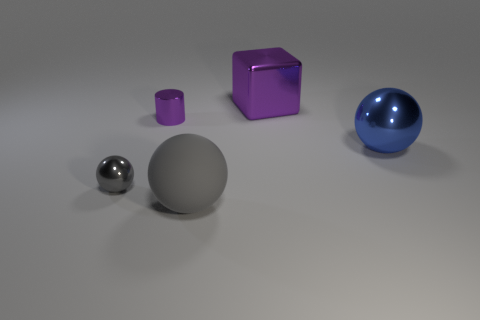What is the color of the other big metallic thing that is the same shape as the gray metallic thing?
Ensure brevity in your answer.  Blue. Is the color of the small metal thing that is in front of the big metallic sphere the same as the metallic cube?
Ensure brevity in your answer.  No. Are there any cylinders left of the small shiny cylinder?
Your answer should be compact. No. There is a shiny object that is behind the small shiny sphere and in front of the tiny cylinder; what is its color?
Provide a short and direct response. Blue. What is the shape of the small object that is the same color as the large matte ball?
Provide a short and direct response. Sphere. What size is the purple object left of the object that is in front of the gray metallic sphere?
Provide a short and direct response. Small. What number of blocks are big things or purple things?
Give a very brief answer. 1. There is a cylinder that is the same size as the gray metal sphere; what is its color?
Offer a terse response. Purple. There is a tiny metallic object in front of the large shiny thing that is in front of the purple metal cylinder; what shape is it?
Your answer should be compact. Sphere. There is a gray matte object that is in front of the gray metal sphere; does it have the same size as the blue sphere?
Give a very brief answer. Yes. 